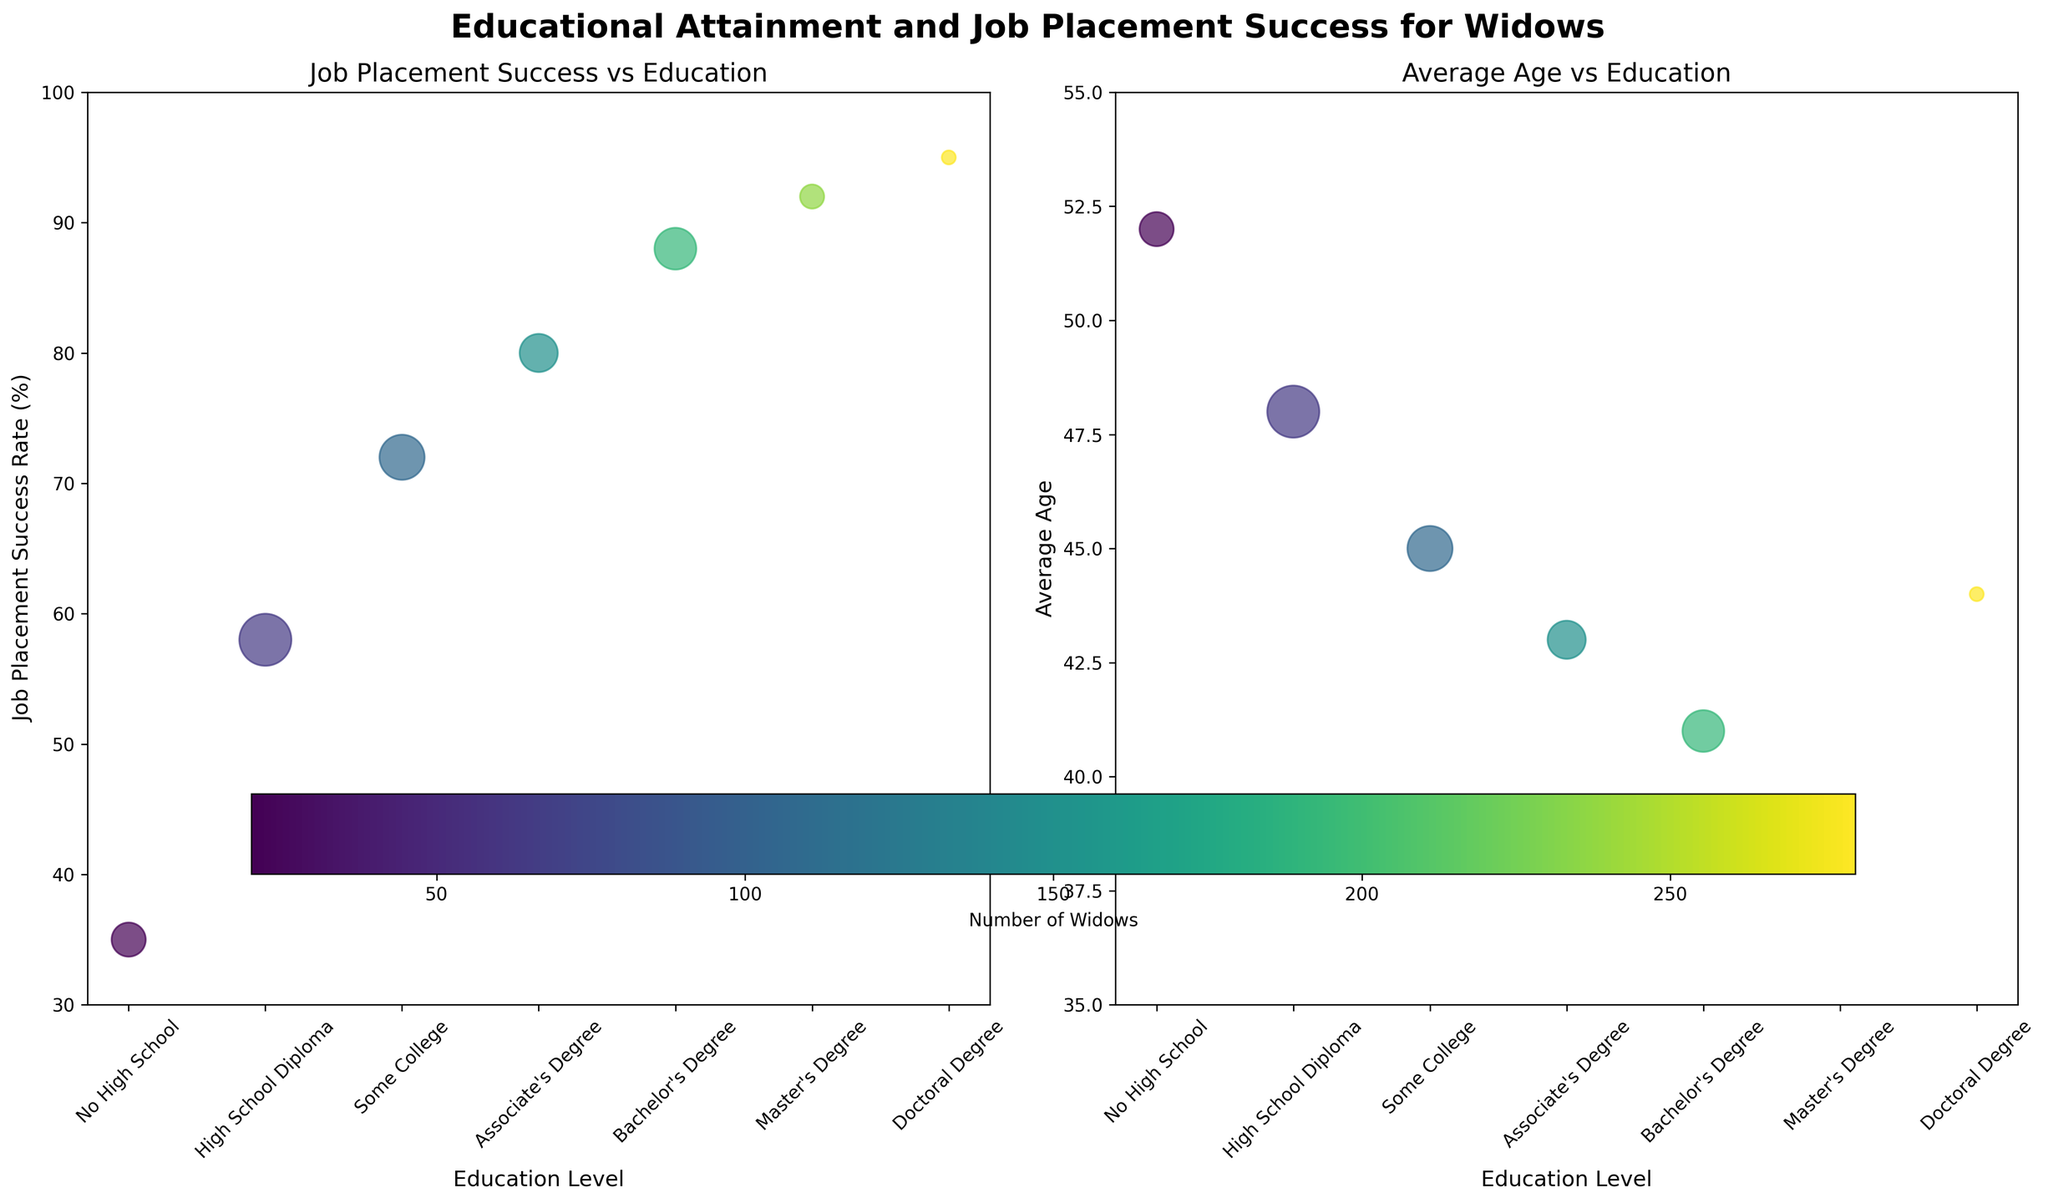How many education levels are represented in the charts? Count the number of unique education levels displayed on the X-axis of both subplots.
Answer: 7 What is the title of the figure? The title is written at the top center of the plot and summarizes the content of the figure.
Answer: Educational Attainment and Job Placement Success for Widows Which education level corresponds to the highest job placement success rate? Observe the Y-axis of the left subplot and find the highest point. Map this point to the corresponding education level on the X-axis.
Answer: Doctoral Degree What is the average age of widows with a Bachelor's Degree? Look at the right subplot and locate the "Bachelor's Degree" on the X-axis. Read off the corresponding Y-axis value.
Answer: 41 Which education level has the largest number of widows? Larger bubbles represent a larger number of widows. Locate the largest bubble in either subplot and identify the corresponding education level.
Answer: High School Diploma What is the difference in job placement success rate between widows with a High School Diploma and a Bachelor's Degree? Find the job placement success rates for both education levels on the left subplot and calculate the difference: 88% (Bachelor's Degree) - 58% (High School Diploma).
Answer: 30% Which education level sees a significant increase in job placement success compared to having no high school education? Compare the job placement success rates of higher education levels to "No High School." Identify the education level with a notable increase.
Answer: High School Diploma How does the average age trend as education level increases? In the right subplot, observe the general trend of the average age as you move from lower to higher education levels on the X-axis.
Answer: Decreases What is the approximate job placement success rate for an Associate's Degree? Look at the left subplot and locate "Associate's Degree" on the X-axis. Read off the corresponding Y-axis value.
Answer: 80% Is there any overlap in the average age range for widows with a Doctoral Degree and those with an Associate's Degree? Check the right subplot. Locate both "Doctoral Degree" and "Associate's Degree" on the X-axis and compare their positions on the Y-axis to determine if their average ages fall within the same range.
Answer: No 